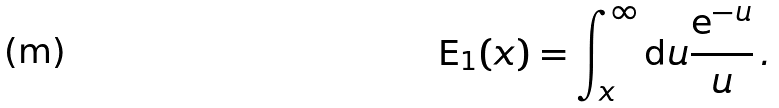<formula> <loc_0><loc_0><loc_500><loc_500>\text {E} _ { 1 } ( x ) = \int _ { x } ^ { \infty } \text {d} u \frac { \text {e} ^ { - u } } { u } \, .</formula> 